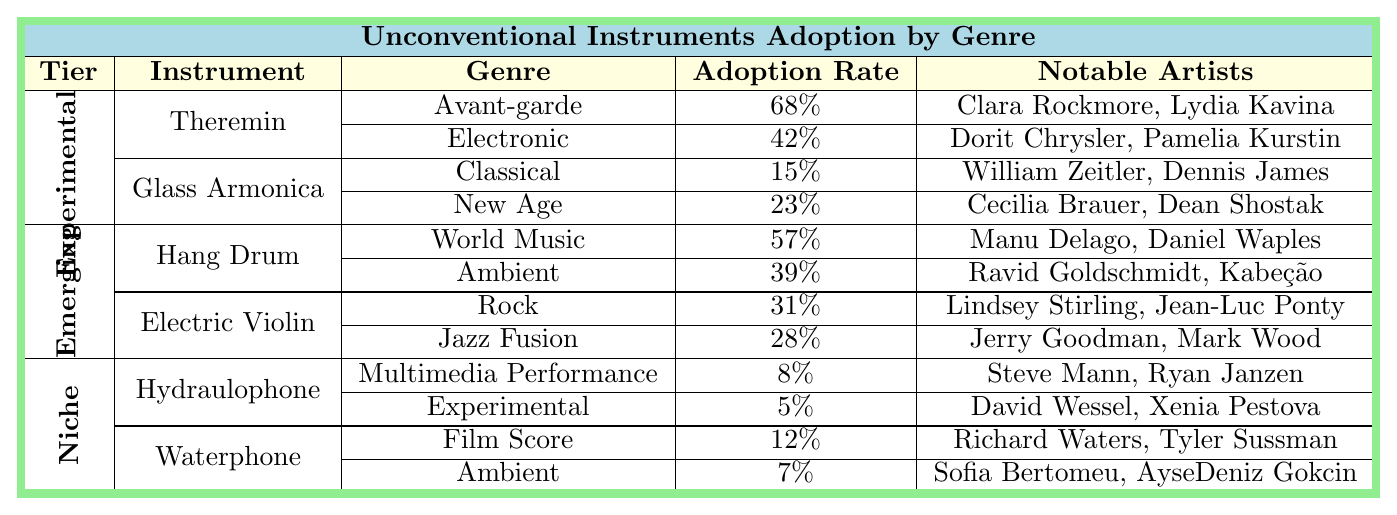What is the adoption rate of the Theremin in the Avant-garde genre? The table shows that the adoption rate of the Theremin in the Avant-garde genre is 68%.
Answer: 68% Which instrument has the highest adoption rate in the Emerging tier? The Hang Drum has an adoption rate of 57%, which is higher than the Electric Violin's adoption rates in the Emerging tier.
Answer: Hang Drum What is the adoption rate of the Waterphone in Ambient music? The table indicates that the adoption rate of the Waterphone in Ambient music is 7%.
Answer: 7% What are the notable artists associated with the Electric Violin in Jazz Fusion? The notable artists associated with the Electric Violin in Jazz Fusion are Jerry Goodman and Mark Wood according to the table.
Answer: Jerry Goodman, Mark Wood Is the adoption rate of Glass Armonica higher in New Age than in Classical? Yes, the adoption rate of Glass Armonica is 23% in New Age, which is higher than the 15% in Classical.
Answer: Yes What is the total adoption rate for the Hang Drum across its genres? The Hang Drum has an adoption rate of 57% in World Music and 39% in Ambient. Adding these gives 57 + 39 = 96%.
Answer: 96% Which tier has the lowest adoption rate for its instruments? The Niche tier has the lowest overall adoption rate, with adoption rates of 8% for Hydraulophone and 12% for Waterphone, compared to rates in Experimental and Emerging tiers.
Answer: Niche How many notable artists are associated with the Theremin? The Theremin has two notable artists: Clara Rockmore and Lydia Kavina, as listed in the table.
Answer: 2 What is the difference in adoption rates between the Glass Armonica in New Age and the Waterphone in Film Score? The Glass Armonica has an adoption rate of 23% in New Age, while the Waterphone has 12% in Film Score. The difference is 23 - 12 = 11%.
Answer: 11% Which genre has the second highest adoption rate for the Hang Drum? The second highest adoption rate for the Hang Drum is 39% in Ambient, after the 57% in World Music.
Answer: Ambient 